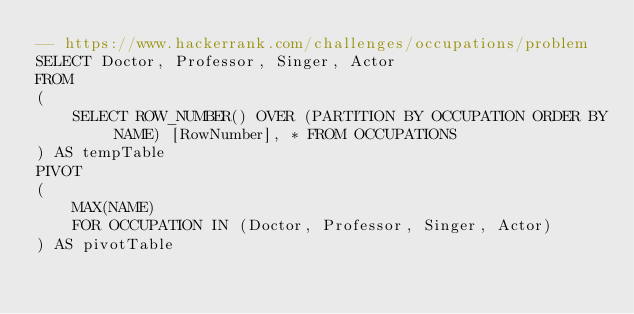<code> <loc_0><loc_0><loc_500><loc_500><_SQL_>-- https://www.hackerrank.com/challenges/occupations/problem
SELECT Doctor, Professor, Singer, Actor
FROM
(
    SELECT ROW_NUMBER() OVER (PARTITION BY OCCUPATION ORDER BY NAME) [RowNumber], * FROM OCCUPATIONS
) AS tempTable
PIVOT
(
    MAX(NAME)
    FOR OCCUPATION IN (Doctor, Professor, Singer, Actor)
) AS pivotTable
</code> 